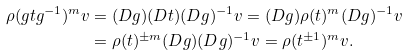Convert formula to latex. <formula><loc_0><loc_0><loc_500><loc_500>\rho ( g t g ^ { - 1 } ) ^ { m } v & = ( D g ) ( D t ) ( D g ) ^ { - 1 } v = ( D g ) \rho ( t ) ^ { m } ( D g ) ^ { - 1 } v \\ & = \rho ( t ) ^ { \pm m } ( D g ) ( D g ) ^ { - 1 } v = \rho ( t ^ { \pm 1 } ) ^ { m } v .</formula> 